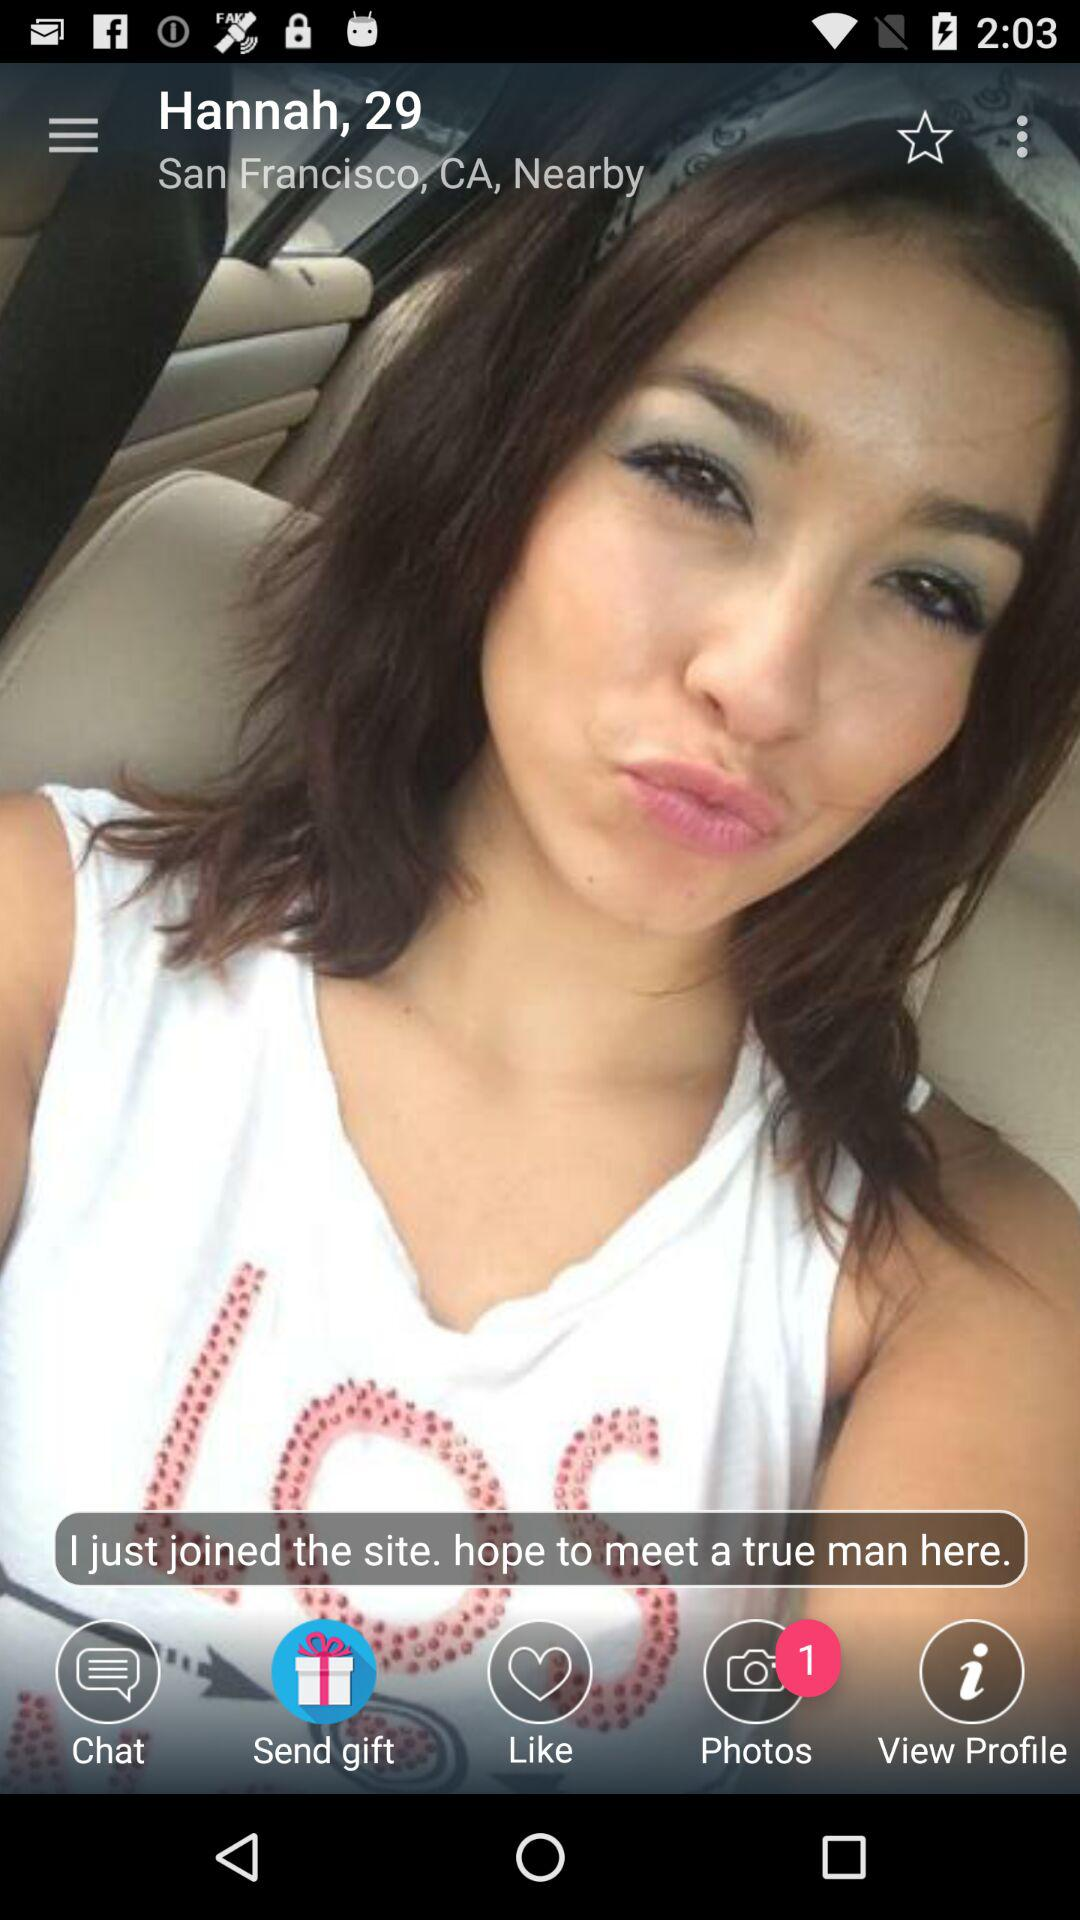What place is shown on the screen? The place shown on the screen is San Francisco, CA. 